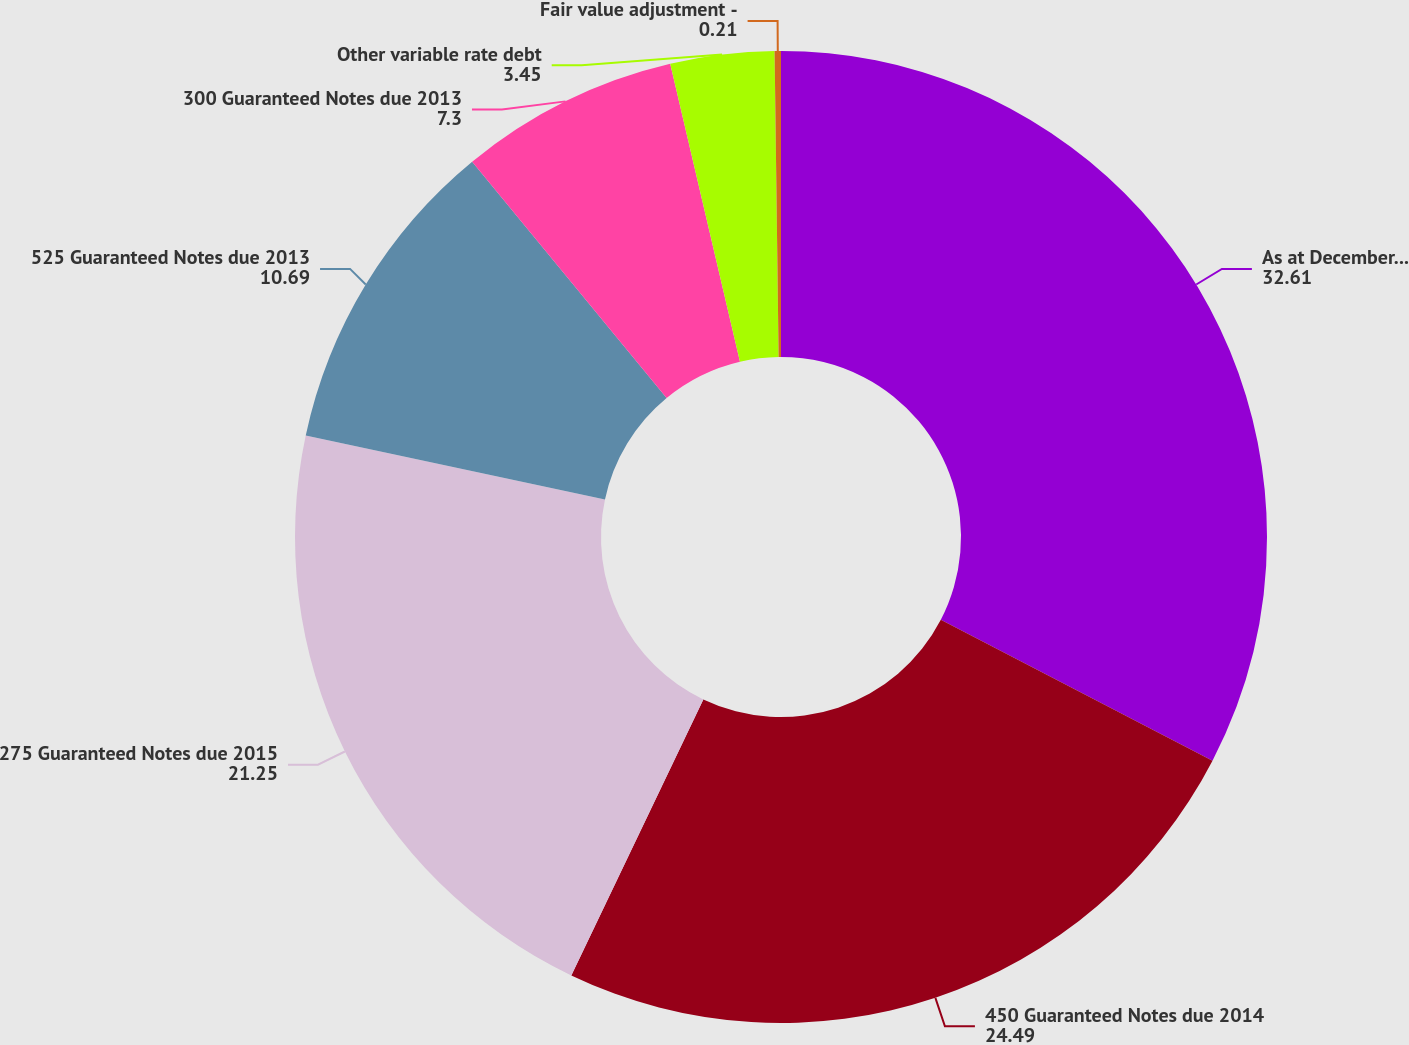<chart> <loc_0><loc_0><loc_500><loc_500><pie_chart><fcel>As at December 31<fcel>450 Guaranteed Notes due 2014<fcel>275 Guaranteed Notes due 2015<fcel>525 Guaranteed Notes due 2013<fcel>300 Guaranteed Notes due 2013<fcel>Other variable rate debt<fcel>Fair value adjustment -<nl><fcel>32.61%<fcel>24.49%<fcel>21.25%<fcel>10.69%<fcel>7.3%<fcel>3.45%<fcel>0.21%<nl></chart> 